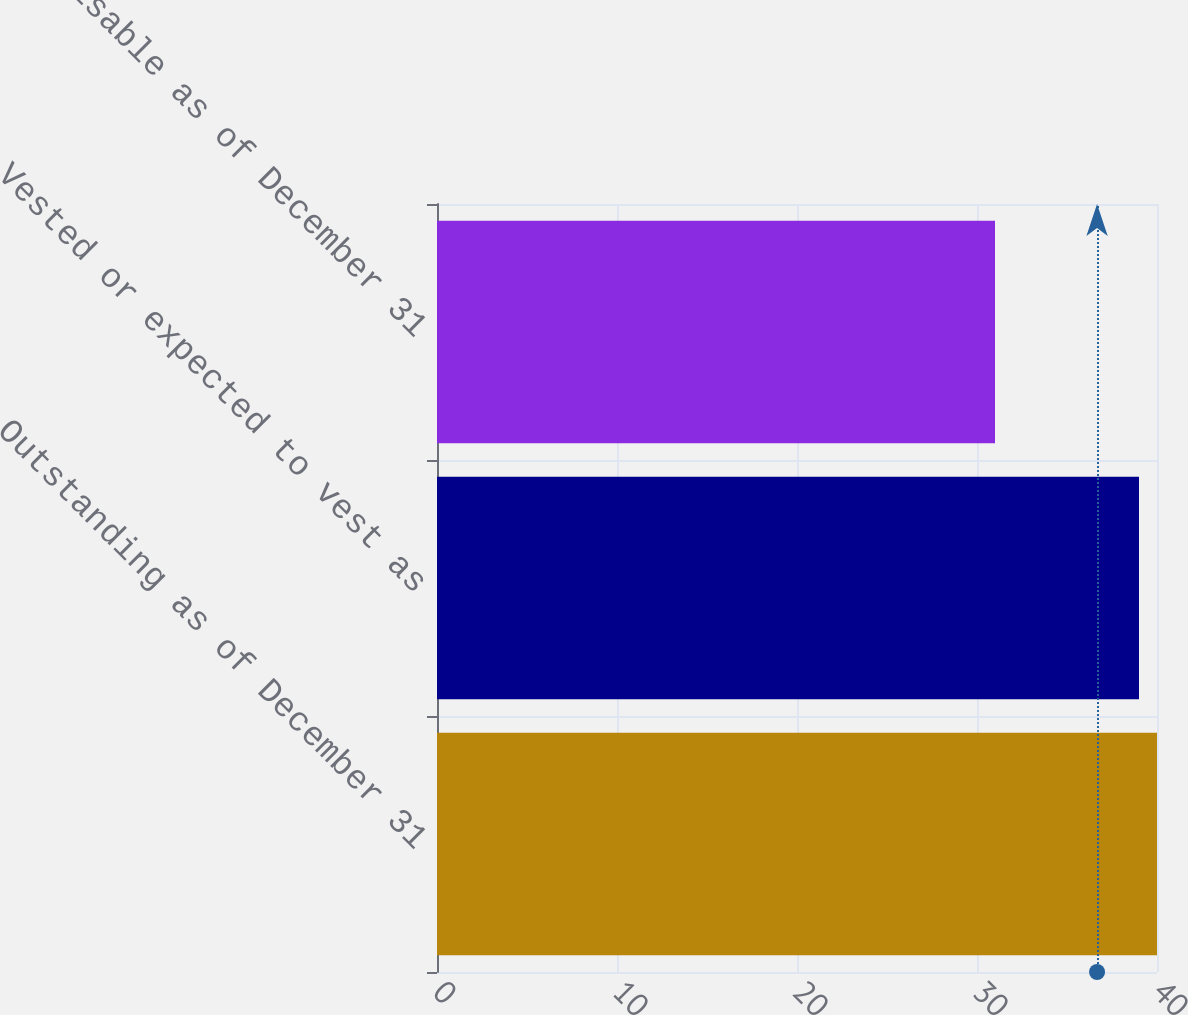Convert chart to OTSL. <chart><loc_0><loc_0><loc_500><loc_500><bar_chart><fcel>Outstanding as of December 31<fcel>Vested or expected to vest as<fcel>Exercisable as of December 31<nl><fcel>40<fcel>39<fcel>31<nl></chart> 